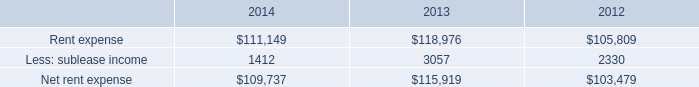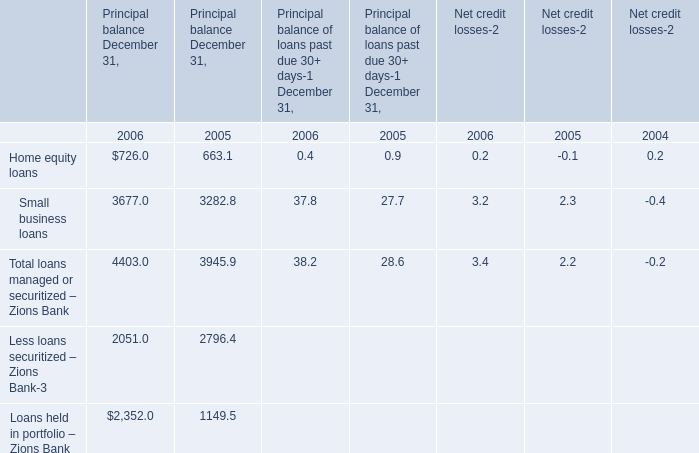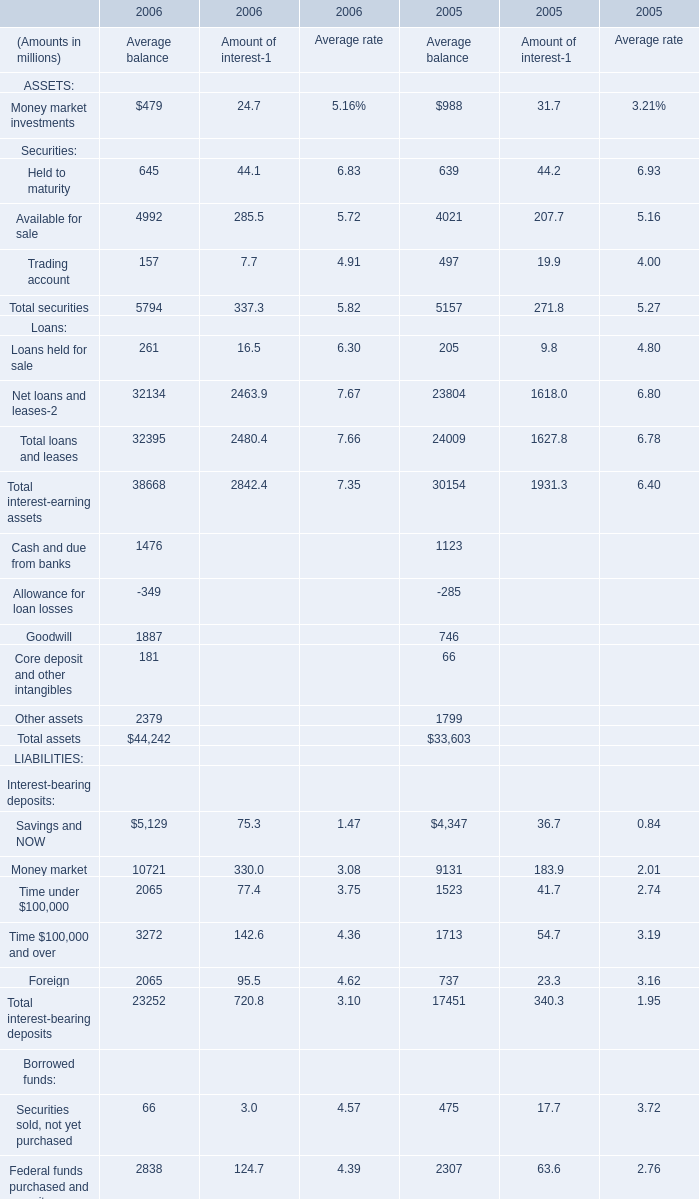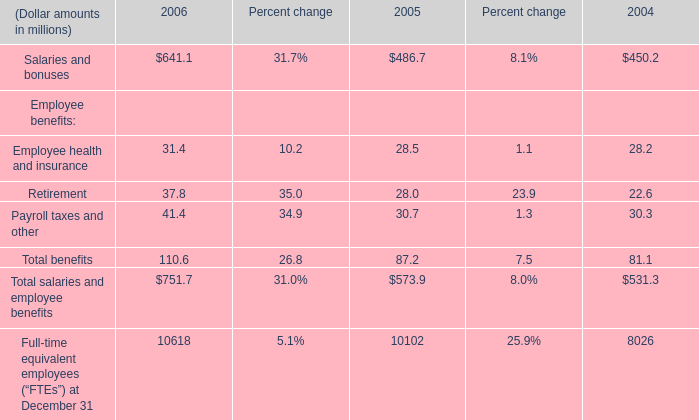what is the growth rate in the net rent expense in 2014? 
Computations: ((109737 - 115919) / 115919)
Answer: -0.05333. 